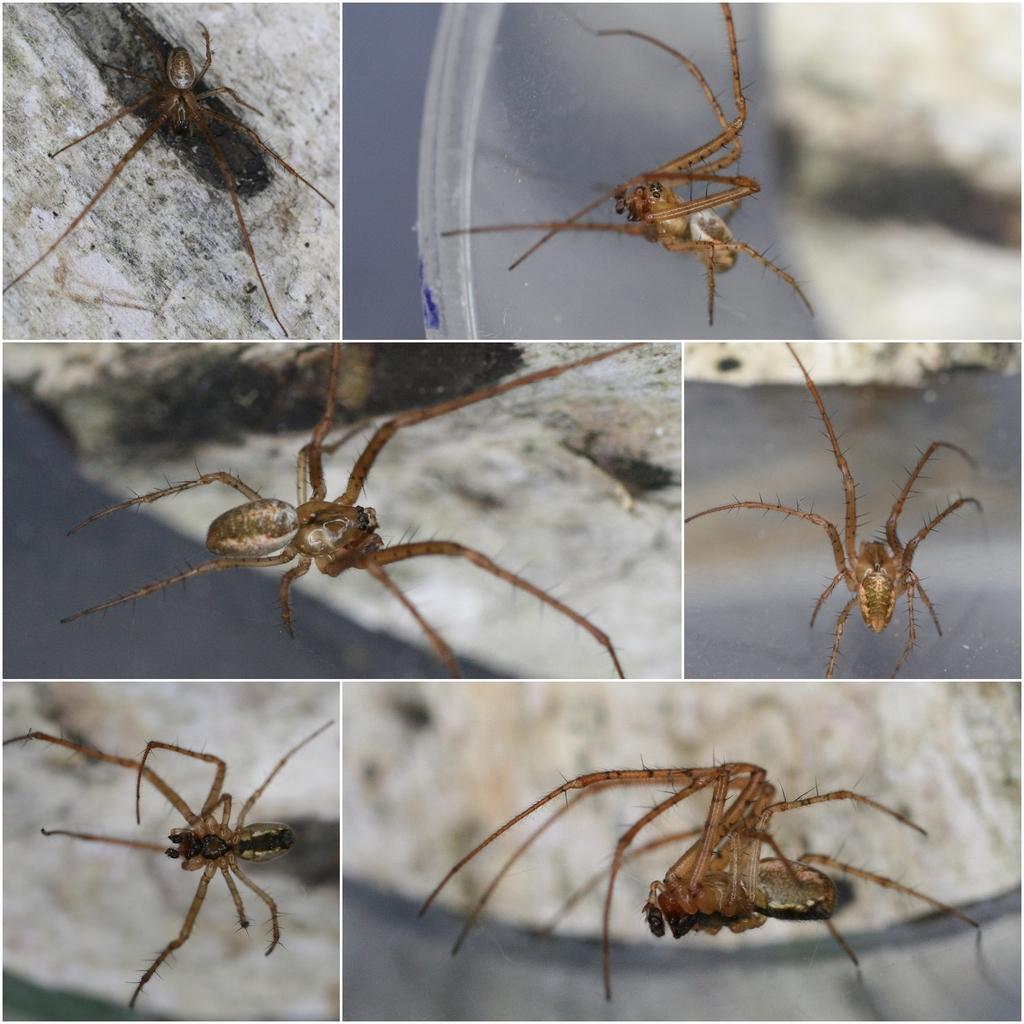Can you describe this image briefly? This is a collage picture, we can see a spider on the path in different angles. 